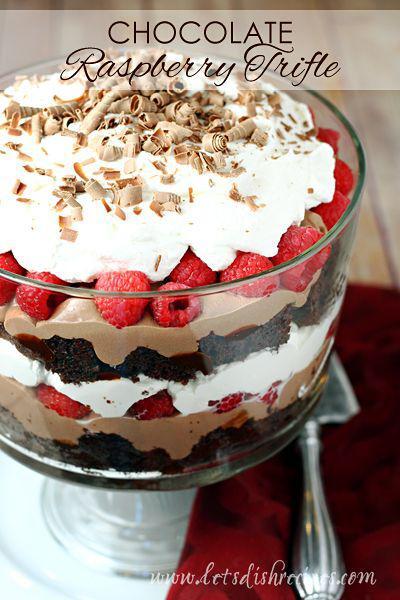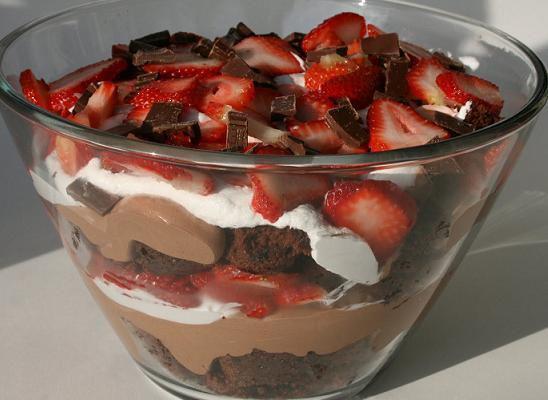The first image is the image on the left, the second image is the image on the right. Examine the images to the left and right. Is the description "In at least one of the images there is a trifle with   multiple strawberries on top." accurate? Answer yes or no. Yes. The first image is the image on the left, the second image is the image on the right. For the images displayed, is the sentence "At least one dessert is garnished with leaves." factually correct? Answer yes or no. No. 